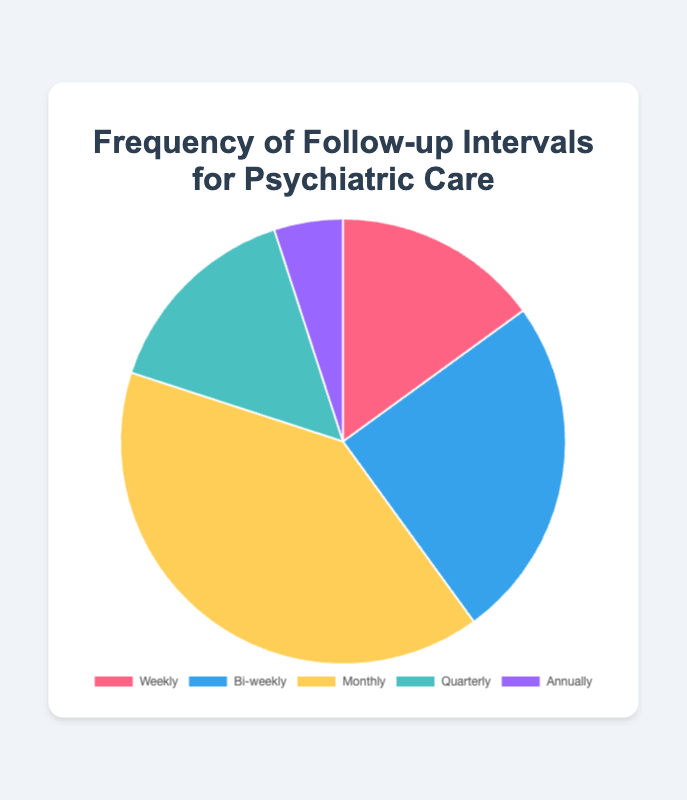How many percentage points more follow-ups are there annually compared to weekly? To find the percentage points difference, subtract the annual percentage (5%) from the weekly percentage (15%).
Answer: 10 Which follow-up interval has the highest frequency? The pie chart shows that the monthly follow-up interval has the largest segment.
Answer: Monthly What is the combined percentage of patients who follow up either weekly or quarterly? Add the percentages of weekly (15%) and quarterly (15%) follow-up intervals: 15 + 15 = 30%.
Answer: 30% Which intervals have the same follow-up frequency? By examining the pie chart, the weekly and quarterly intervals each have a frequency of 15%.
Answer: Weekly and Quarterly What percentage of follow-ups occur more frequently than quarterly? The intervals more frequent than quarterly are weekly, bi-weekly, and monthly. Add their percentages: 15% (weekly) + 25% (bi-weekly) + 40% (monthly) = 80%.
Answer: 80% Compare the frequencies of monthly and bi-weekly follow-ups. Which one is higher and by how much? Monthly follow-ups have a frequency of 40%, whereas bi-weekly follow-ups have a frequency of 25%. Subtract 25 from 40: 40 - 25 = 15%.
Answer: Monthly, 15% Which follow-up interval has the smallest proportion of patients? The smallest segment on the pie chart represents the annually follow-up interval, which is 5%.
Answer: Annually If a random patient is selected, what is the probability that they follow up either monthly or bi-weekly? Add the frequencies of monthly (40%) and bi-weekly (25%) follow-ups: 40 + 25 = 65%.
Answer: 65% Consider the quarterly and annually follow-up intervals. What is their combined percentage? Adding the percentages for quarterly (15%) and annually (5%): 15 + 5 = 20%.
Answer: 20% What is the difference in percentages between the highest and the lowest follow-up intervals? The highest follow-up frequency is monthly (40%) and the lowest is annually (5%). Subtract 5 from 40: 40 - 5 = 35%.
Answer: 35% 